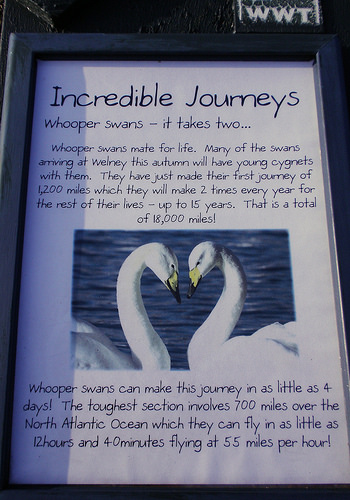<image>
Can you confirm if the duck is in the book? Yes. The duck is contained within or inside the book, showing a containment relationship. 